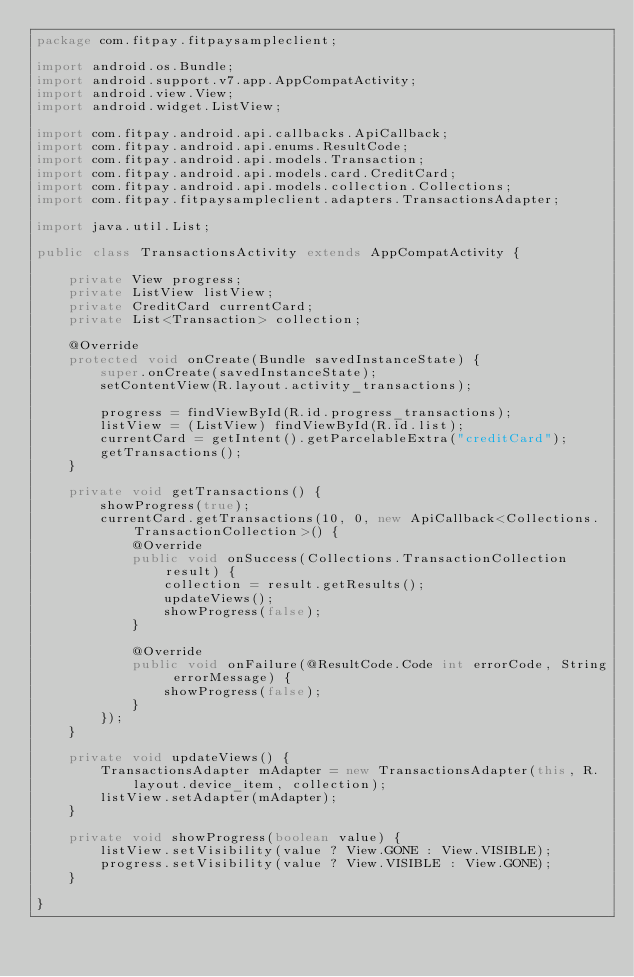Convert code to text. <code><loc_0><loc_0><loc_500><loc_500><_Java_>package com.fitpay.fitpaysampleclient;

import android.os.Bundle;
import android.support.v7.app.AppCompatActivity;
import android.view.View;
import android.widget.ListView;

import com.fitpay.android.api.callbacks.ApiCallback;
import com.fitpay.android.api.enums.ResultCode;
import com.fitpay.android.api.models.Transaction;
import com.fitpay.android.api.models.card.CreditCard;
import com.fitpay.android.api.models.collection.Collections;
import com.fitpay.fitpaysampleclient.adapters.TransactionsAdapter;

import java.util.List;

public class TransactionsActivity extends AppCompatActivity {

    private View progress;
    private ListView listView;
    private CreditCard currentCard;
    private List<Transaction> collection;

    @Override
    protected void onCreate(Bundle savedInstanceState) {
        super.onCreate(savedInstanceState);
        setContentView(R.layout.activity_transactions);

        progress = findViewById(R.id.progress_transactions);
        listView = (ListView) findViewById(R.id.list);
        currentCard = getIntent().getParcelableExtra("creditCard");
        getTransactions();
    }

    private void getTransactions() {
        showProgress(true);
        currentCard.getTransactions(10, 0, new ApiCallback<Collections.TransactionCollection>() {
            @Override
            public void onSuccess(Collections.TransactionCollection result) {
                collection = result.getResults();
                updateViews();
                showProgress(false);
            }

            @Override
            public void onFailure(@ResultCode.Code int errorCode, String errorMessage) {
                showProgress(false);
            }
        });
    }

    private void updateViews() {
        TransactionsAdapter mAdapter = new TransactionsAdapter(this, R.layout.device_item, collection);
        listView.setAdapter(mAdapter);
    }

    private void showProgress(boolean value) {
        listView.setVisibility(value ? View.GONE : View.VISIBLE);
        progress.setVisibility(value ? View.VISIBLE : View.GONE);
    }

}
</code> 